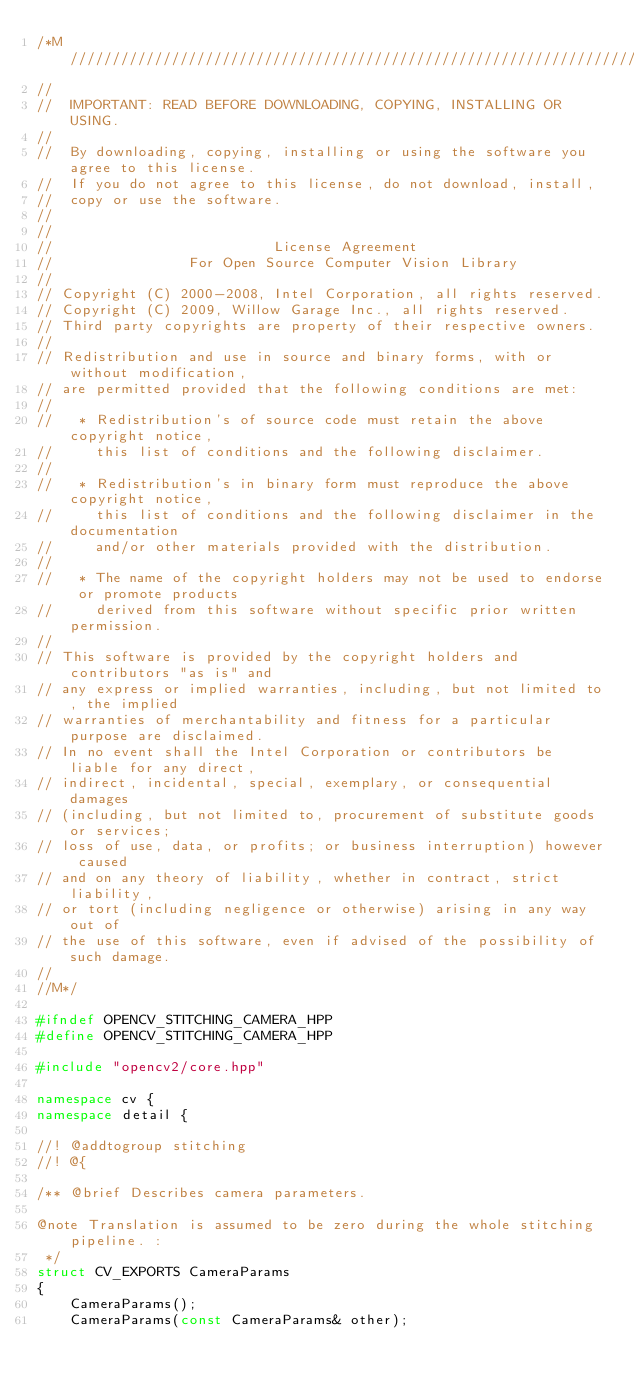<code> <loc_0><loc_0><loc_500><loc_500><_C++_>/*M///////////////////////////////////////////////////////////////////////////////////////
//
//  IMPORTANT: READ BEFORE DOWNLOADING, COPYING, INSTALLING OR USING.
//
//  By downloading, copying, installing or using the software you agree to this license.
//  If you do not agree to this license, do not download, install,
//  copy or use the software.
//
//
//                          License Agreement
//                For Open Source Computer Vision Library
//
// Copyright (C) 2000-2008, Intel Corporation, all rights reserved.
// Copyright (C) 2009, Willow Garage Inc., all rights reserved.
// Third party copyrights are property of their respective owners.
//
// Redistribution and use in source and binary forms, with or without modification,
// are permitted provided that the following conditions are met:
//
//   * Redistribution's of source code must retain the above copyright notice,
//     this list of conditions and the following disclaimer.
//
//   * Redistribution's in binary form must reproduce the above copyright notice,
//     this list of conditions and the following disclaimer in the documentation
//     and/or other materials provided with the distribution.
//
//   * The name of the copyright holders may not be used to endorse or promote products
//     derived from this software without specific prior written permission.
//
// This software is provided by the copyright holders and contributors "as is" and
// any express or implied warranties, including, but not limited to, the implied
// warranties of merchantability and fitness for a particular purpose are disclaimed.
// In no event shall the Intel Corporation or contributors be liable for any direct,
// indirect, incidental, special, exemplary, or consequential damages
// (including, but not limited to, procurement of substitute goods or services;
// loss of use, data, or profits; or business interruption) however caused
// and on any theory of liability, whether in contract, strict liability,
// or tort (including negligence or otherwise) arising in any way out of
// the use of this software, even if advised of the possibility of such damage.
//
//M*/

#ifndef OPENCV_STITCHING_CAMERA_HPP
#define OPENCV_STITCHING_CAMERA_HPP

#include "opencv2/core.hpp"

namespace cv {
namespace detail {

//! @addtogroup stitching
//! @{

/** @brief Describes camera parameters.

@note Translation is assumed to be zero during the whole stitching pipeline. :
 */
struct CV_EXPORTS CameraParams
{
    CameraParams();
    CameraParams(const CameraParams& other);</code> 